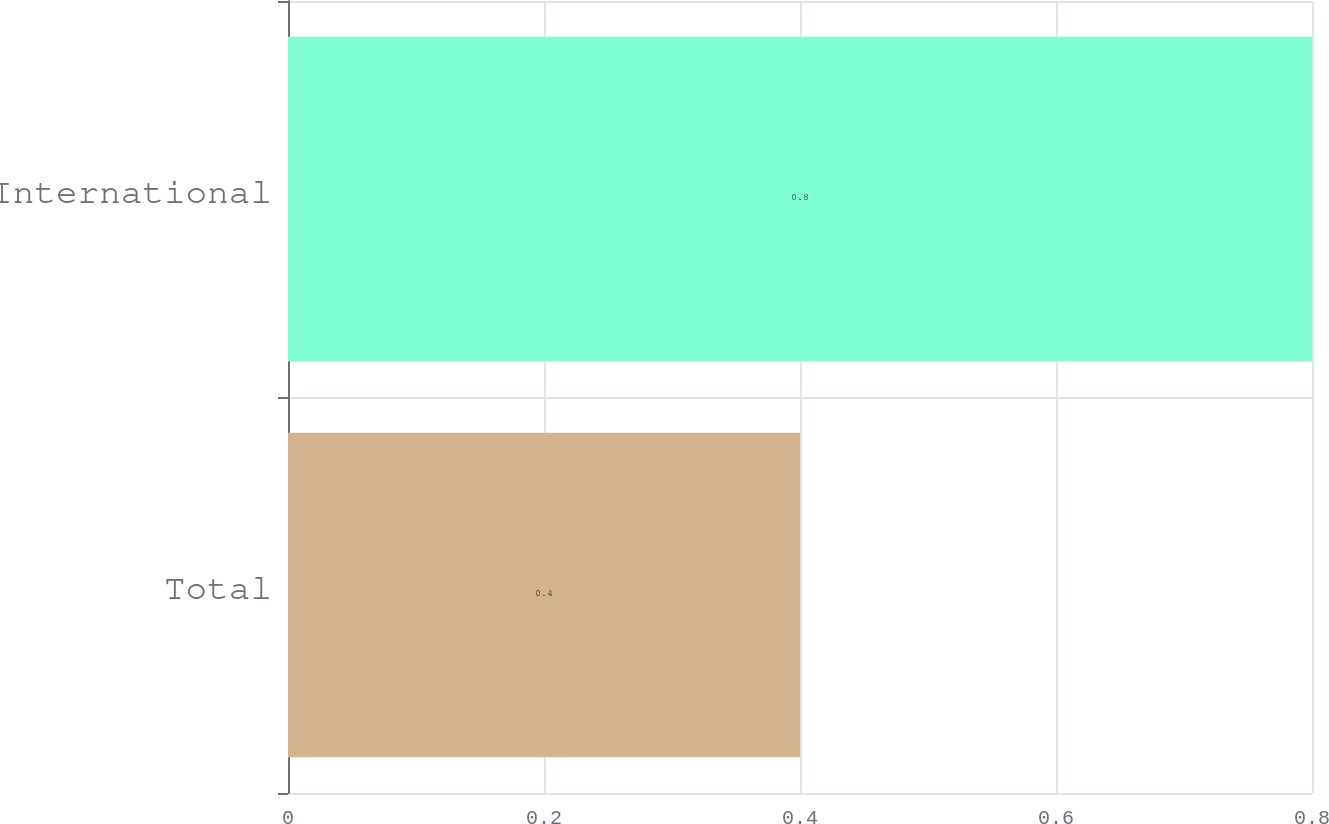Convert chart to OTSL. <chart><loc_0><loc_0><loc_500><loc_500><bar_chart><fcel>Total<fcel>International<nl><fcel>0.4<fcel>0.8<nl></chart> 